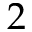Convert formula to latex. <formula><loc_0><loc_0><loc_500><loc_500>2</formula> 